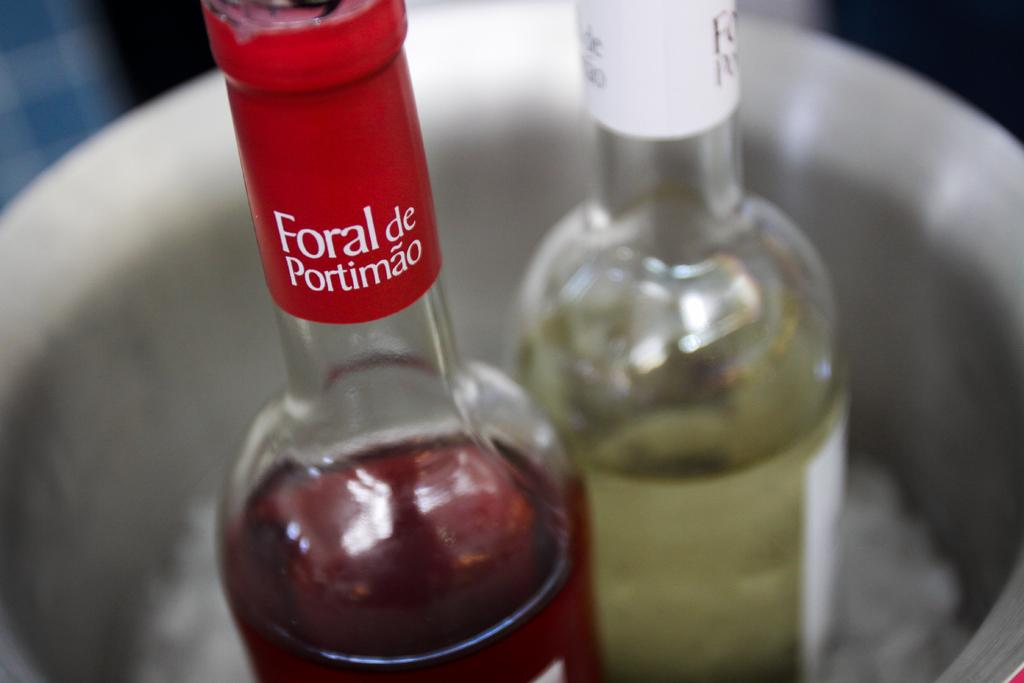<image>
Provide a brief description of the given image. A bottle of Foral de Porimao sits in a bucket next to a white wine. 